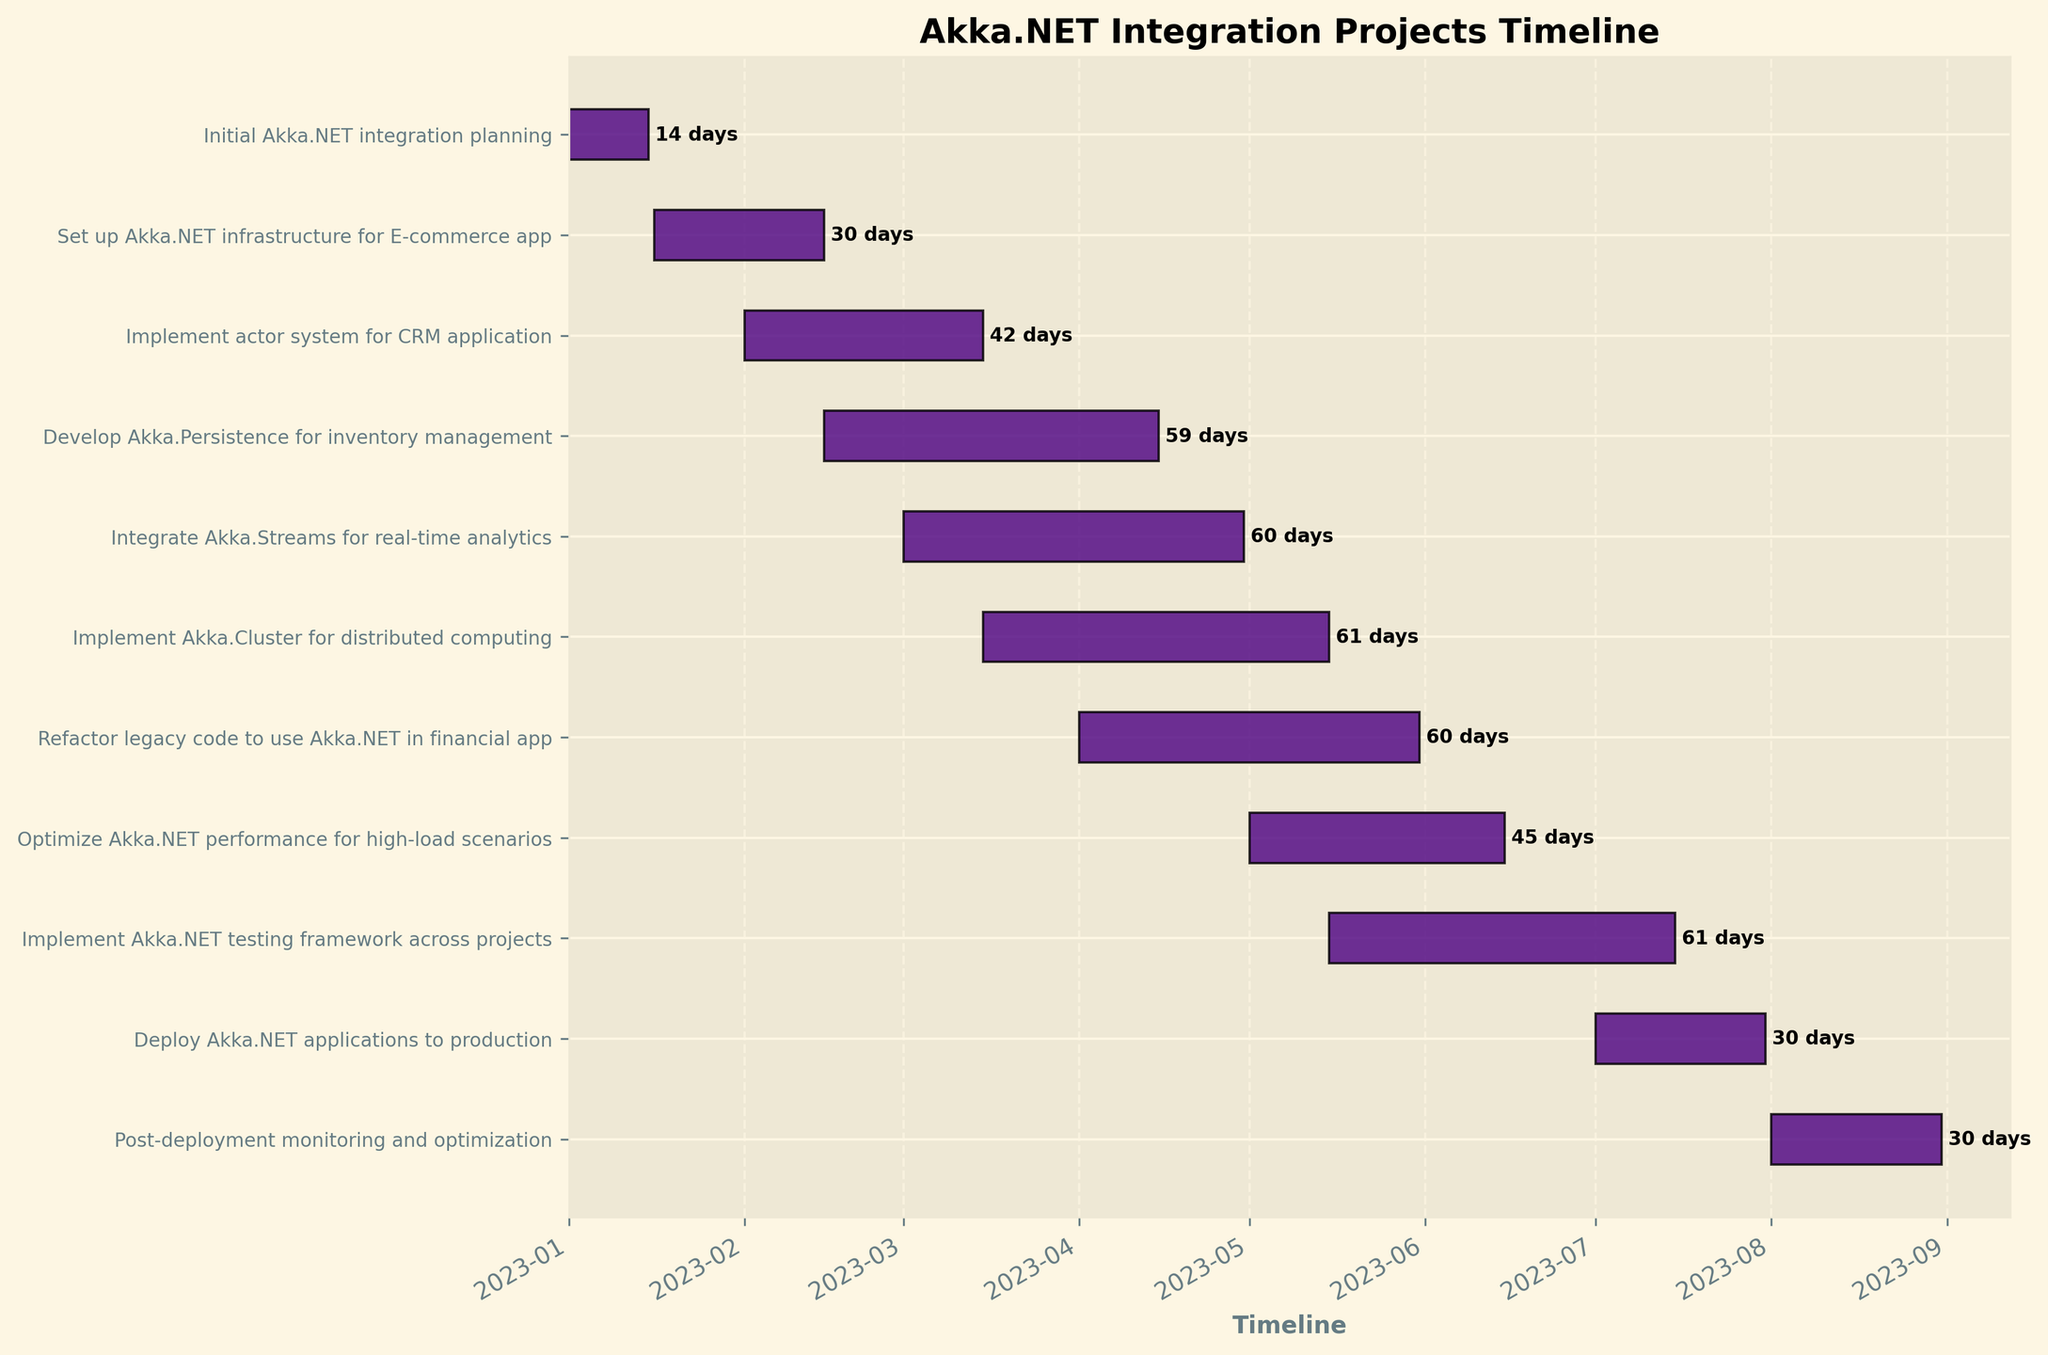How many tasks are displayed on the timeline? Count the total number of bars depicted in the Gantt chart which represent the tasks.
Answer: 11 Which task has the longest duration? Identify the bar with the greatest length from start date to end date to determine the longest duration task.
Answer: Implement Akka.Cluster for distributed computing What are the start and end dates for the "Integrate Akka.Streams for real-time analytics" task? Locate the "Integrate Akka.Streams for real-time analytics" label on the y-axis, then trace its corresponding bar to the x-axis to find its start and end dates.
Answer: Start: 2023-03-01, End: 2023-04-30 Which tasks overlap with the "Implement Akka.Cluster for distributed computing" task? Identify the start and end dates of the "Implement Akka.Cluster for distributed computing" task, then look for other tasks whose time spans overlap with this period.
Answer: Integrate Akka.Streams for real-time analytics, Develop Akka.Persistence for inventory management, Refactor legacy code to use Akka.NET in financial app, Optimize Akka.NET performance for high-load scenarios, Implement Akka.NET testing framework across projects What are the overlapping periods between "Develop Akka.Persistence for inventory management" and "Integrate Akka.Streams for real-time analytics"? "Develop Akka.Persistence for inventory management" runs from 2023-02-15 to 2023-04-15, and "Integrate Akka.Streams for real-time analytics" runs from 2023-03-01 to 2023-04-30. The overlapping period is from 2023-03-01 to 2023-04-15, where both tasks are active.
Answer: 2023-03-01 to 2023-04-15 Between which dates is only one task active? Examine the beginning and ending of all tasks, finding periods where only one task is active. The period when "Initial Akka.NET integration planning" is the only active task fits the criteria.
Answer: 2023-01-01 to 2023-01-15 How many tasks are active as of May 1, 2023? Identify the tasks that have start dates before or on May 1, 2023, and end dates after or on May 1, 2023. Count the number of such tasks.
Answer: 5 tasks Which task ends just before the "Deploy Akka.NET applications to production" task begins? Find the start date of "Deploy Akka.NET applications to production," then identify the task that has an end date immediately before it.
Answer: Implement Akka.NET testing framework across projects How many tasks extend beyond April 2023? Identify and count tasks that have end dates after April 2023.
Answer: 7 tasks 